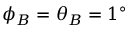Convert formula to latex. <formula><loc_0><loc_0><loc_500><loc_500>\phi _ { B } = \theta _ { B } = 1 ^ { \circ }</formula> 